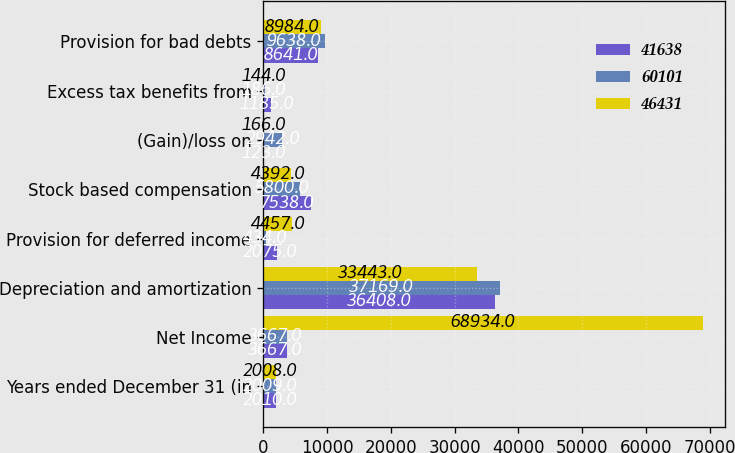<chart> <loc_0><loc_0><loc_500><loc_500><stacked_bar_chart><ecel><fcel>Years ended December 31 (in<fcel>Net Income<fcel>Depreciation and amortization<fcel>Provision for deferred income<fcel>Stock based compensation<fcel>(Gain)/loss on<fcel>Excess tax benefits from<fcel>Provision for bad debts<nl><fcel>41638<fcel>2010<fcel>3667<fcel>36408<fcel>2075<fcel>7538<fcel>123<fcel>1185<fcel>8641<nl><fcel>60101<fcel>2009<fcel>3667<fcel>37169<fcel>434<fcel>5800<fcel>2942<fcel>186<fcel>9638<nl><fcel>46431<fcel>2008<fcel>68934<fcel>33443<fcel>4457<fcel>4392<fcel>166<fcel>144<fcel>8984<nl></chart> 